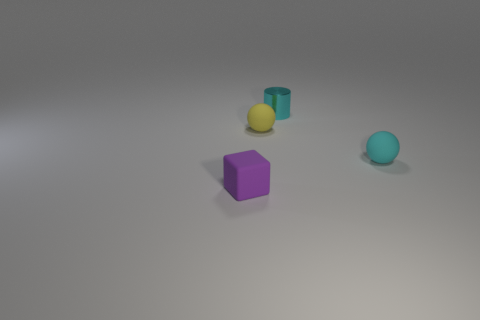Is there any other thing that has the same shape as the purple thing?
Provide a succinct answer. No. There is another rubber object that is the same shape as the cyan matte thing; what color is it?
Your answer should be very brief. Yellow. There is a tiny ball that is on the left side of the cylinder; what is its material?
Keep it short and to the point. Rubber. The rubber cube is what color?
Your answer should be very brief. Purple. What material is the tiny cyan thing behind the rubber object that is behind the tiny rubber ball on the right side of the yellow sphere?
Provide a succinct answer. Metal. Do the thing that is to the right of the cyan cylinder and the tiny thing that is behind the yellow matte object have the same color?
Give a very brief answer. Yes. What material is the small cyan cylinder on the left side of the tiny rubber ball in front of the tiny yellow thing?
Provide a short and direct response. Metal. There is a cube that is the same size as the yellow rubber thing; what color is it?
Keep it short and to the point. Purple. There is a tiny yellow thing; does it have the same shape as the tiny cyan thing on the right side of the tiny cyan cylinder?
Your answer should be very brief. Yes. There is a object that is the same color as the tiny metal cylinder; what shape is it?
Your answer should be compact. Sphere. 